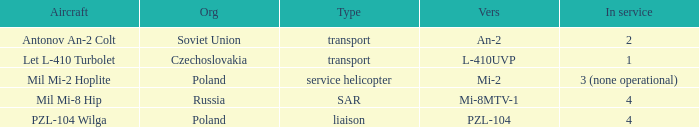Help me parse the entirety of this table. {'header': ['Aircraft', 'Org', 'Type', 'Vers', 'In service'], 'rows': [['Antonov An-2 Colt', 'Soviet Union', 'transport', 'An-2', '2'], ['Let L-410 Turbolet', 'Czechoslovakia', 'transport', 'L-410UVP', '1'], ['Mil Mi-2 Hoplite', 'Poland', 'service helicopter', 'Mi-2', '3 (none operational)'], ['Mil Mi-8 Hip', 'Russia', 'SAR', 'Mi-8MTV-1', '4'], ['PZL-104 Wilga', 'Poland', 'liaison', 'PZL-104', '4']]} Tell me the service for versions l-410uvp 1.0. 